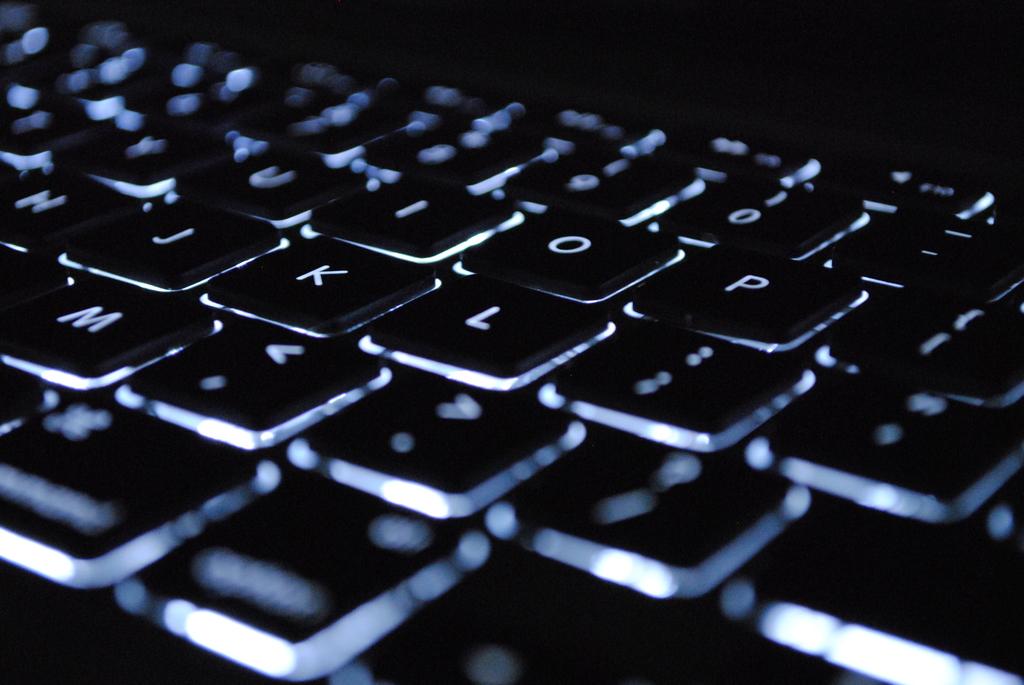What key is below o and p?
Your answer should be very brief. L. What kind of board is this?
Offer a terse response. Answering does not require reading text in the image. 